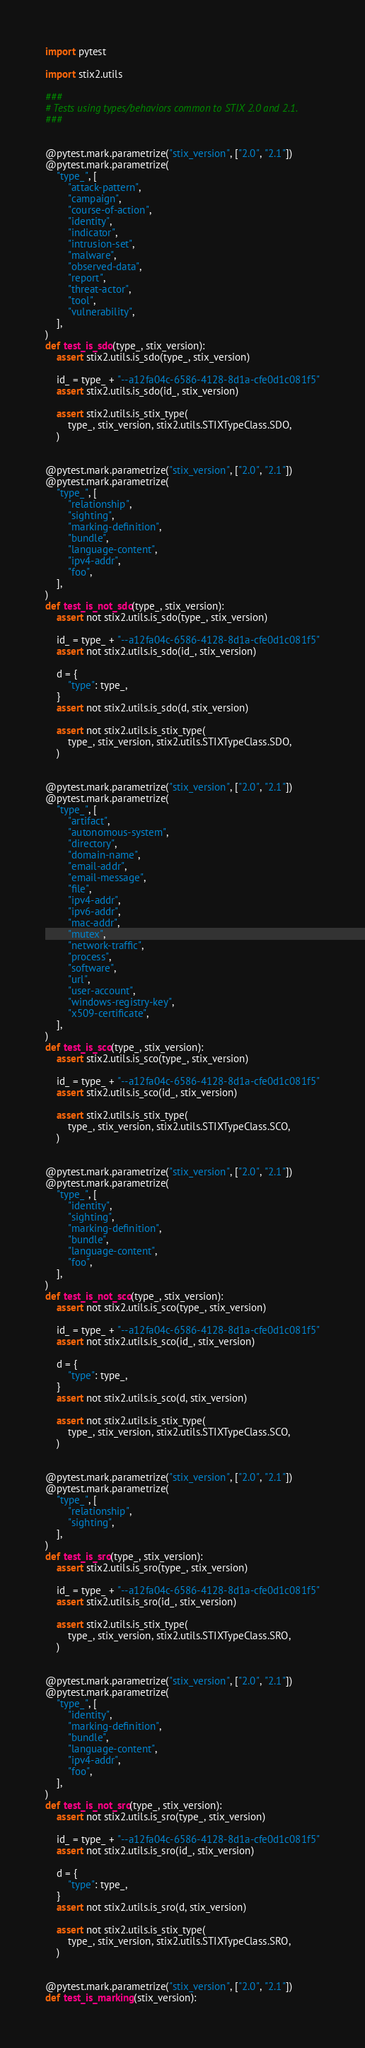<code> <loc_0><loc_0><loc_500><loc_500><_Python_>import pytest

import stix2.utils

###
# Tests using types/behaviors common to STIX 2.0 and 2.1.
###


@pytest.mark.parametrize("stix_version", ["2.0", "2.1"])
@pytest.mark.parametrize(
    "type_", [
        "attack-pattern",
        "campaign",
        "course-of-action",
        "identity",
        "indicator",
        "intrusion-set",
        "malware",
        "observed-data",
        "report",
        "threat-actor",
        "tool",
        "vulnerability",
    ],
)
def test_is_sdo(type_, stix_version):
    assert stix2.utils.is_sdo(type_, stix_version)

    id_ = type_ + "--a12fa04c-6586-4128-8d1a-cfe0d1c081f5"
    assert stix2.utils.is_sdo(id_, stix_version)

    assert stix2.utils.is_stix_type(
        type_, stix_version, stix2.utils.STIXTypeClass.SDO,
    )


@pytest.mark.parametrize("stix_version", ["2.0", "2.1"])
@pytest.mark.parametrize(
    "type_", [
        "relationship",
        "sighting",
        "marking-definition",
        "bundle",
        "language-content",
        "ipv4-addr",
        "foo",
    ],
)
def test_is_not_sdo(type_, stix_version):
    assert not stix2.utils.is_sdo(type_, stix_version)

    id_ = type_ + "--a12fa04c-6586-4128-8d1a-cfe0d1c081f5"
    assert not stix2.utils.is_sdo(id_, stix_version)

    d = {
        "type": type_,
    }
    assert not stix2.utils.is_sdo(d, stix_version)

    assert not stix2.utils.is_stix_type(
        type_, stix_version, stix2.utils.STIXTypeClass.SDO,
    )


@pytest.mark.parametrize("stix_version", ["2.0", "2.1"])
@pytest.mark.parametrize(
    "type_", [
        "artifact",
        "autonomous-system",
        "directory",
        "domain-name",
        "email-addr",
        "email-message",
        "file",
        "ipv4-addr",
        "ipv6-addr",
        "mac-addr",
        "mutex",
        "network-traffic",
        "process",
        "software",
        "url",
        "user-account",
        "windows-registry-key",
        "x509-certificate",
    ],
)
def test_is_sco(type_, stix_version):
    assert stix2.utils.is_sco(type_, stix_version)

    id_ = type_ + "--a12fa04c-6586-4128-8d1a-cfe0d1c081f5"
    assert stix2.utils.is_sco(id_, stix_version)

    assert stix2.utils.is_stix_type(
        type_, stix_version, stix2.utils.STIXTypeClass.SCO,
    )


@pytest.mark.parametrize("stix_version", ["2.0", "2.1"])
@pytest.mark.parametrize(
    "type_", [
        "identity",
        "sighting",
        "marking-definition",
        "bundle",
        "language-content",
        "foo",
    ],
)
def test_is_not_sco(type_, stix_version):
    assert not stix2.utils.is_sco(type_, stix_version)

    id_ = type_ + "--a12fa04c-6586-4128-8d1a-cfe0d1c081f5"
    assert not stix2.utils.is_sco(id_, stix_version)

    d = {
        "type": type_,
    }
    assert not stix2.utils.is_sco(d, stix_version)

    assert not stix2.utils.is_stix_type(
        type_, stix_version, stix2.utils.STIXTypeClass.SCO,
    )


@pytest.mark.parametrize("stix_version", ["2.0", "2.1"])
@pytest.mark.parametrize(
    "type_", [
        "relationship",
        "sighting",
    ],
)
def test_is_sro(type_, stix_version):
    assert stix2.utils.is_sro(type_, stix_version)

    id_ = type_ + "--a12fa04c-6586-4128-8d1a-cfe0d1c081f5"
    assert stix2.utils.is_sro(id_, stix_version)

    assert stix2.utils.is_stix_type(
        type_, stix_version, stix2.utils.STIXTypeClass.SRO,
    )


@pytest.mark.parametrize("stix_version", ["2.0", "2.1"])
@pytest.mark.parametrize(
    "type_", [
        "identity",
        "marking-definition",
        "bundle",
        "language-content",
        "ipv4-addr",
        "foo",
    ],
)
def test_is_not_sro(type_, stix_version):
    assert not stix2.utils.is_sro(type_, stix_version)

    id_ = type_ + "--a12fa04c-6586-4128-8d1a-cfe0d1c081f5"
    assert not stix2.utils.is_sro(id_, stix_version)

    d = {
        "type": type_,
    }
    assert not stix2.utils.is_sro(d, stix_version)

    assert not stix2.utils.is_stix_type(
        type_, stix_version, stix2.utils.STIXTypeClass.SRO,
    )


@pytest.mark.parametrize("stix_version", ["2.0", "2.1"])
def test_is_marking(stix_version):</code> 